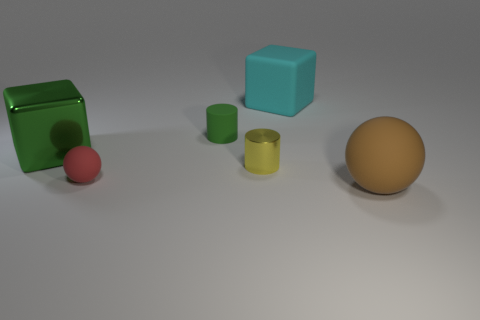Add 4 big purple rubber cylinders. How many objects exist? 10 Subtract all cylinders. How many objects are left? 4 Add 6 tiny metal objects. How many tiny metal objects are left? 7 Add 1 brown spheres. How many brown spheres exist? 2 Subtract 0 purple blocks. How many objects are left? 6 Subtract all big purple metal objects. Subtract all matte spheres. How many objects are left? 4 